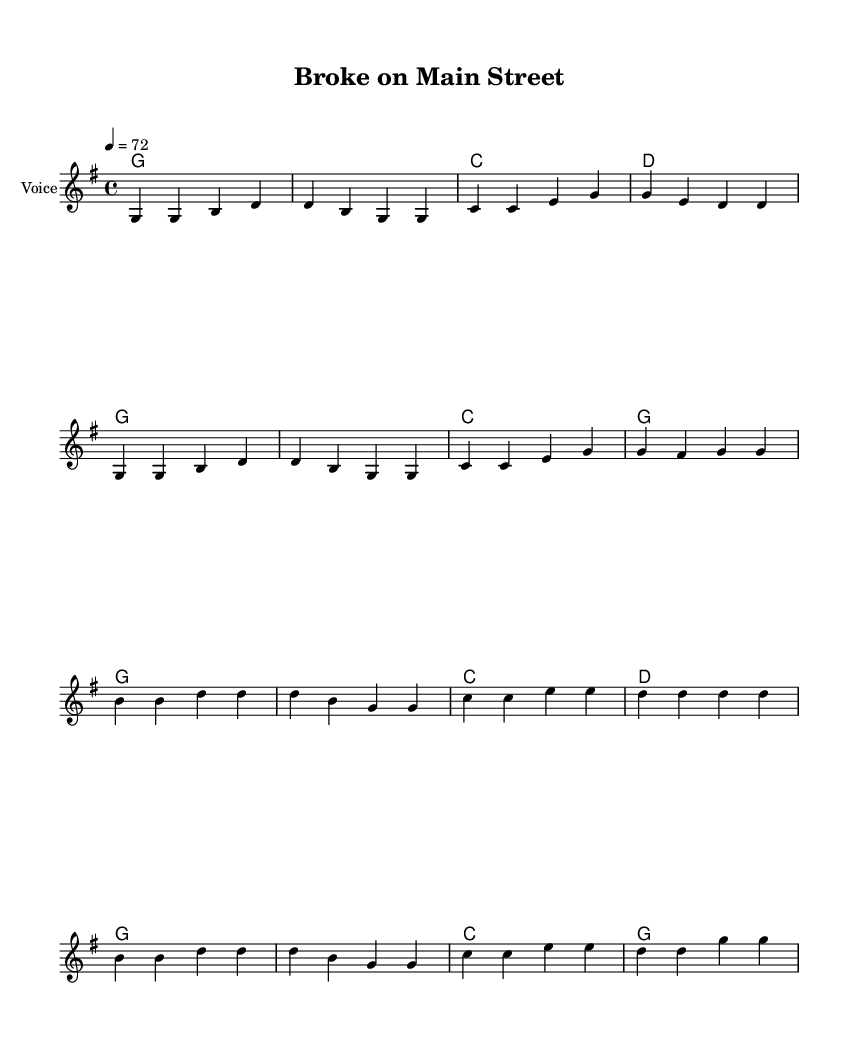What is the key signature of this music? The key signature is G major, which has one sharp (F#). This is determined by looking at the key indication marked at the beginning of the staff.
Answer: G major What is the time signature of this music? The time signature is 4/4, shown at the beginning of the score as two numbers stacked, indicating four beats per measure with the quarter note receiving one beat.
Answer: 4/4 What is the tempo marking for this piece? The tempo marking is quarter note = 72, specified at the beginning of the score, indicating the speed at which the piece should be played.
Answer: 72 How many lines are in the staff? There are five lines in the staff, which is standard for treble clef notation seen in the score.
Answer: Five lines What is the chord progression used in the chorus? The chord progression for the chorus is G, C, D, which corresponds to the chords written above the melody for the chorus section.
Answer: G, C, D What theme does the song lyrics address? The song lyrics address economic hardships in rural America, highlighting struggles and resilience in the face of financial difficulties.
Answer: Economic hardships What emotion is emphasized in the lyrics of the song? The emotion emphasized in the lyrics is hope, as indicated by phrases like "holding on to hope" despite the hard times faced.
Answer: Hope 